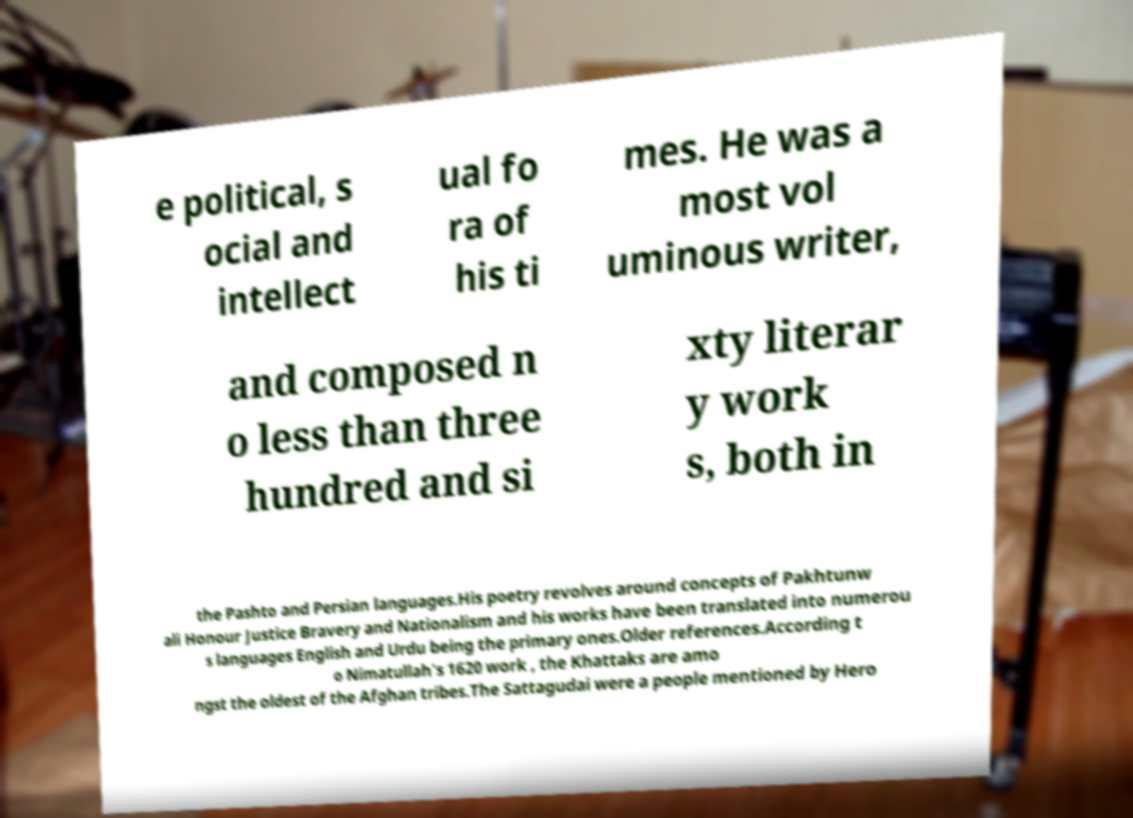Please read and relay the text visible in this image. What does it say? e political, s ocial and intellect ual fo ra of his ti mes. He was a most vol uminous writer, and composed n o less than three hundred and si xty literar y work s, both in the Pashto and Persian languages.His poetry revolves around concepts of Pakhtunw ali Honour Justice Bravery and Nationalism and his works have been translated into numerou s languages English and Urdu being the primary ones.Older references.According t o Nimatullah's 1620 work , the Khattaks are amo ngst the oldest of the Afghan tribes.The Sattagudai were a people mentioned by Hero 